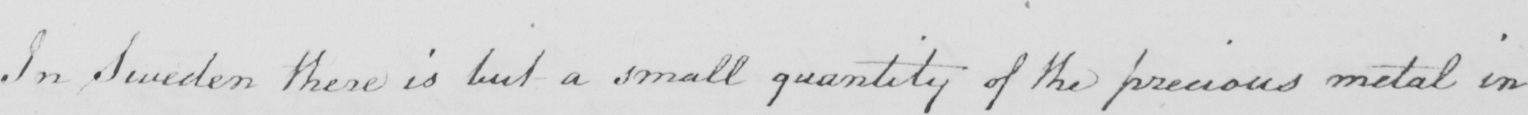What text is written in this handwritten line? In Sweden there is but a small quantity of the precious metal in 